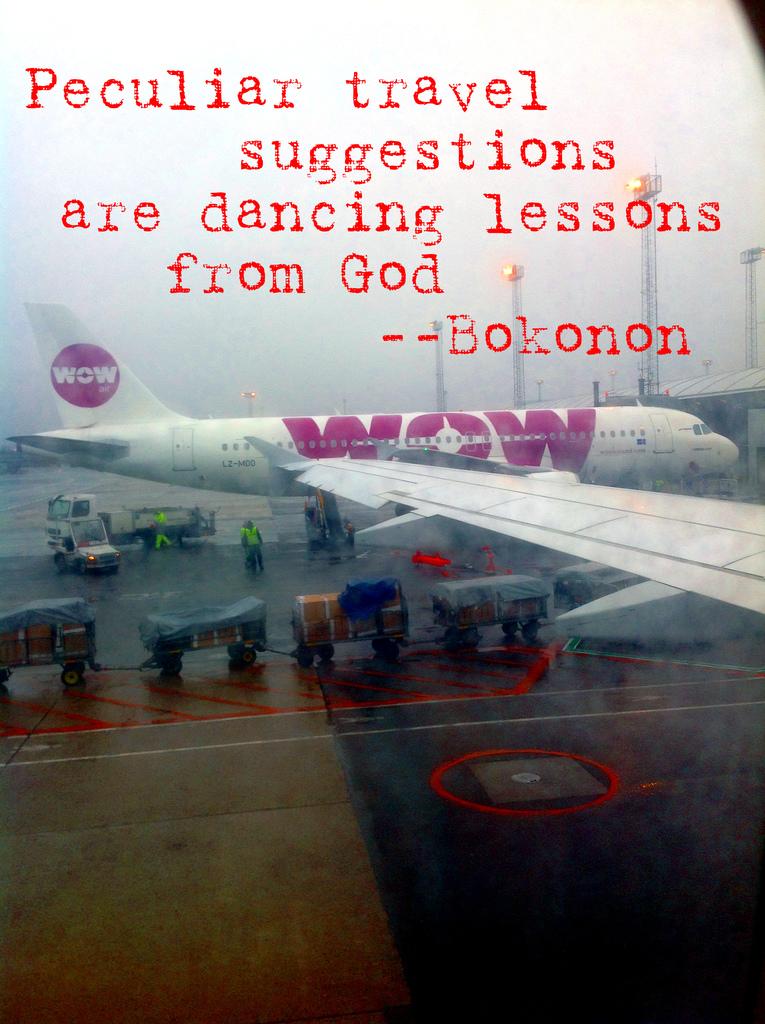What is the airline shown?
Ensure brevity in your answer.  Wow. Who said that "peculiar travel suggestions are dancing lessons from god?"?
Offer a terse response. Bokonon. 